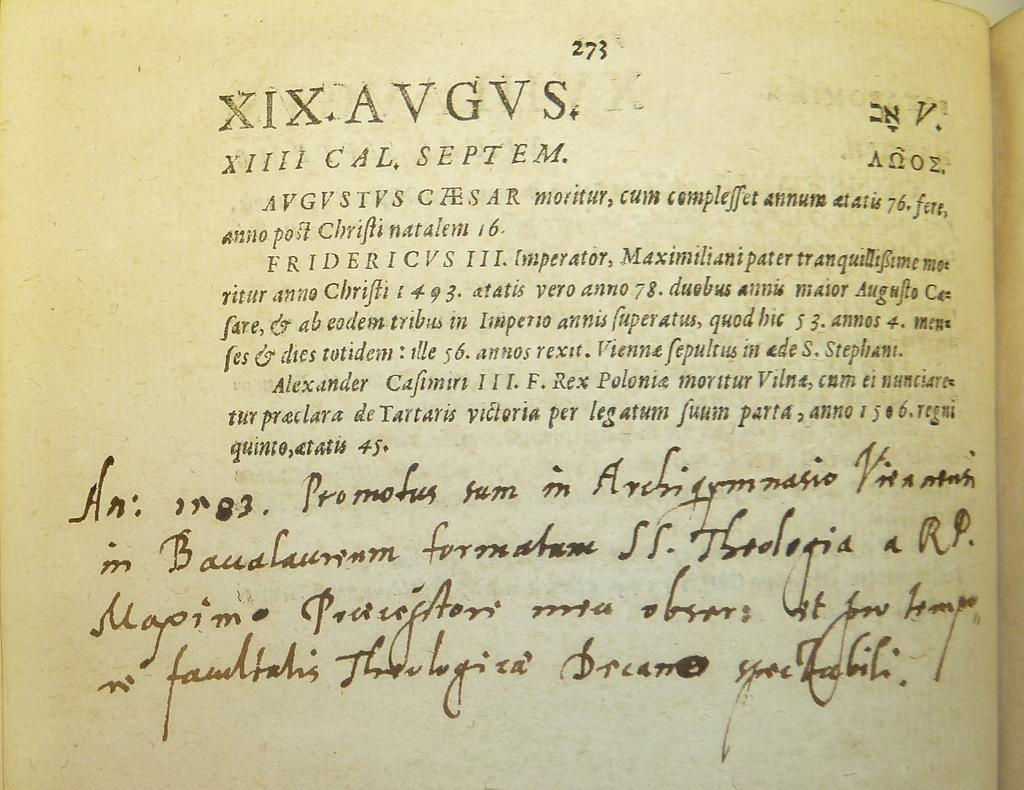<image>
Give a short and clear explanation of the subsequent image. Page 273 of a very old text book has some printing and some hand written notes. 